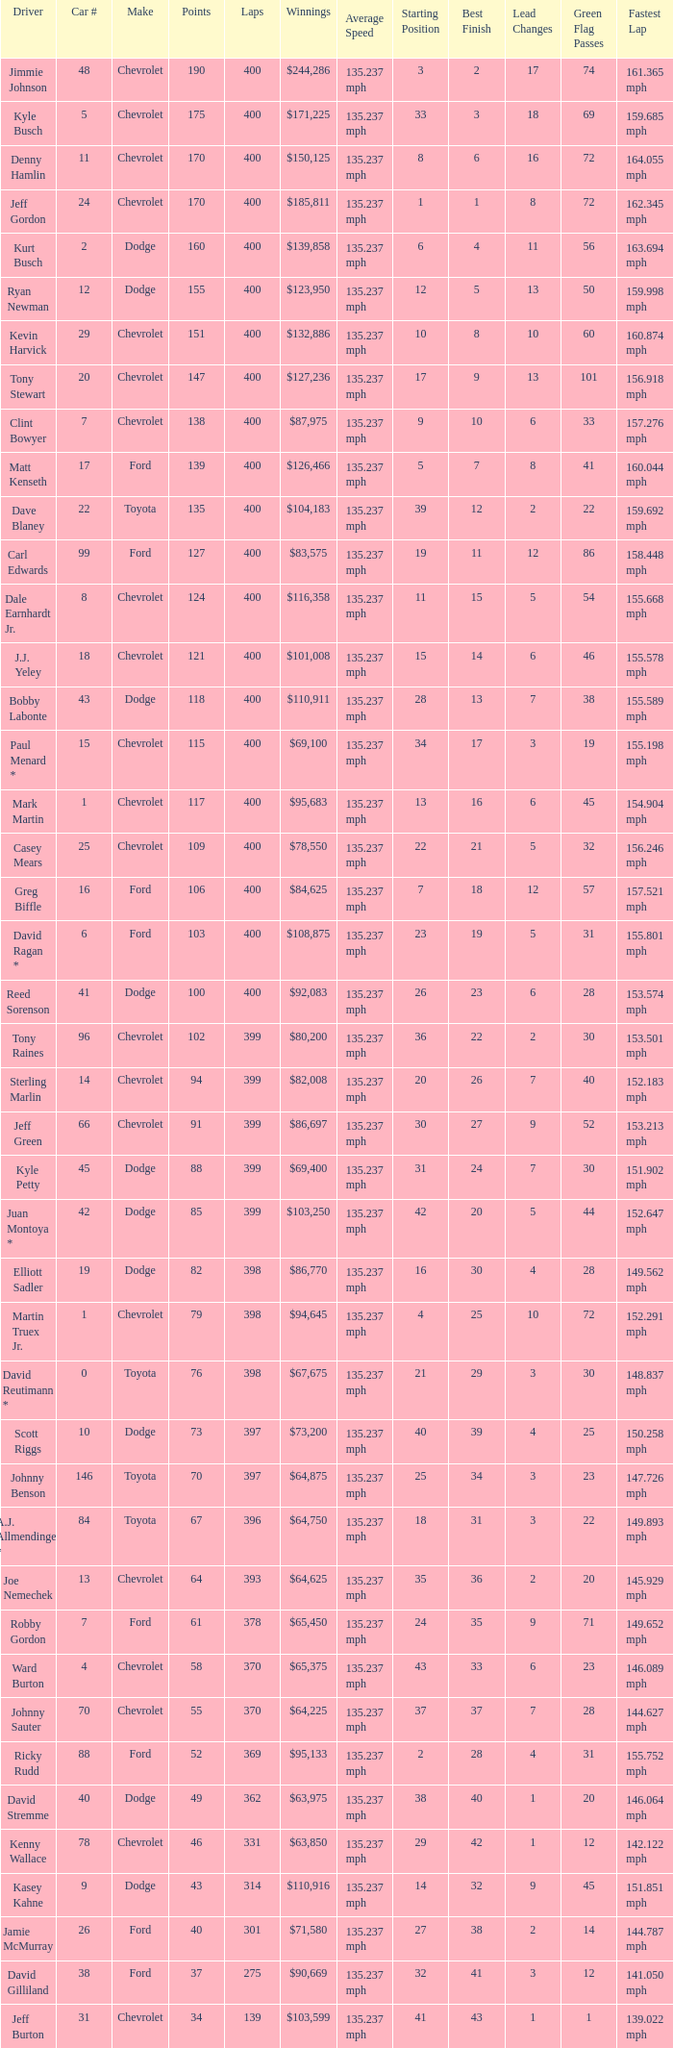What is the car number that has less than 369 laps for a Dodge with more than 49 points? None. 